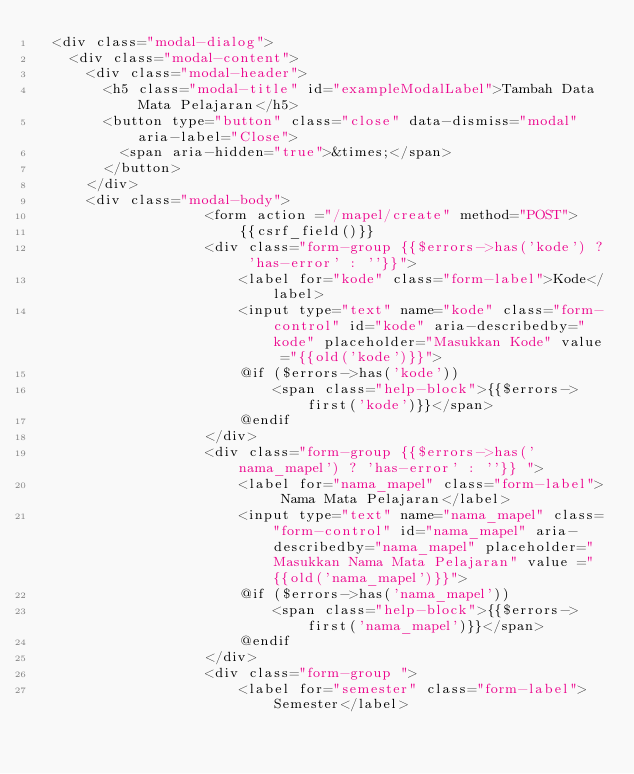Convert code to text. <code><loc_0><loc_0><loc_500><loc_500><_PHP_>  <div class="modal-dialog">
    <div class="modal-content">
      <div class="modal-header">
        <h5 class="modal-title" id="exampleModalLabel">Tambah Data Mata Pelajaran</h5>
        <button type="button" class="close" data-dismiss="modal" aria-label="Close">
          <span aria-hidden="true">&times;</span>
        </button>
      </div>
      <div class="modal-body">
                    <form action ="/mapel/create" method="POST">
                        {{csrf_field()}}
                    <div class="form-group {{$errors->has('kode') ? 'has-error' : ''}}">
                        <label for="kode" class="form-label">Kode</label>
                        <input type="text" name="kode" class="form-control" id="kode" aria-describedby="kode" placeholder="Masukkan Kode" value ="{{old('kode')}}">
                        @if ($errors->has('kode'))
                            <span class="help-block">{{$errors->first('kode')}}</span>
                        @endif
                    </div>
                    <div class="form-group {{$errors->has('nama_mapel') ? 'has-error' : ''}} ">
                        <label for="nama_mapel" class="form-label"> Nama Mata Pelajaran</label>
                        <input type="text" name="nama_mapel" class="form-control" id="nama_mapel" aria-describedby="nama_mapel" placeholder="Masukkan Nama Mata Pelajaran" value ="{{old('nama_mapel')}}">
                        @if ($errors->has('nama_mapel'))
                            <span class="help-block">{{$errors->first('nama_mapel')}}</span>
                        @endif
                    </div>
                    <div class="form-group ">
                        <label for="semester" class="form-label">Semester</label></code> 